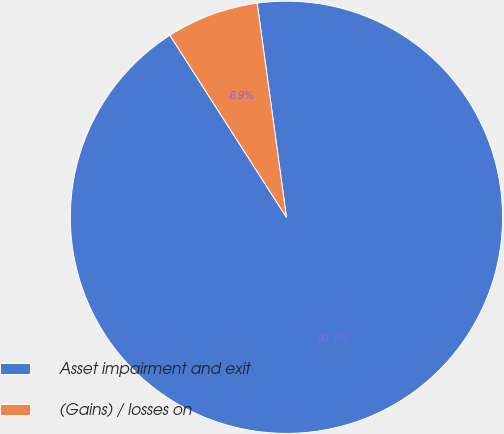Convert chart. <chart><loc_0><loc_0><loc_500><loc_500><pie_chart><fcel>Asset impairment and exit<fcel>(Gains) / losses on<nl><fcel>93.1%<fcel>6.9%<nl></chart> 